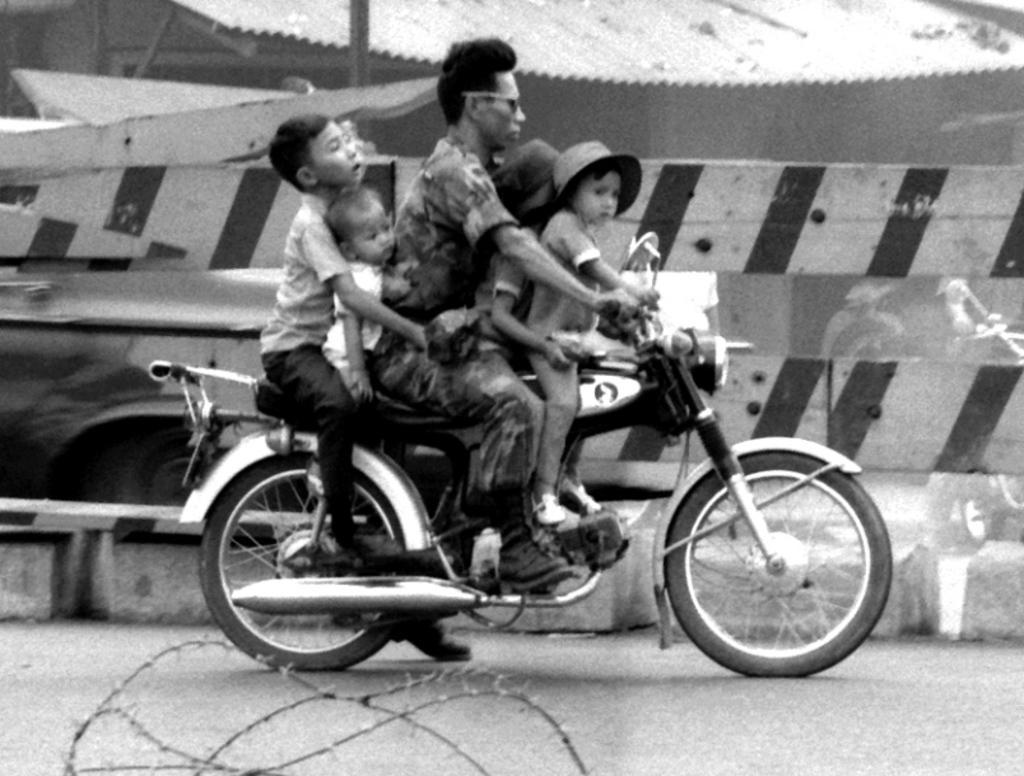Please provide a concise description of this image. In this black and white picture we can see five persons sitting on a bike. This is a road. This is a fence. 